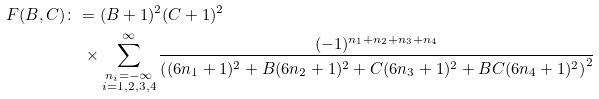Convert formula to latex. <formula><loc_0><loc_0><loc_500><loc_500>F ( B , C ) & \colon = ( B + 1 ) ^ { 2 } ( C + 1 ) ^ { 2 } \\ & \quad \times \sum _ { \substack { n _ { i } = - \infty \\ i = 1 , 2 , 3 , 4 } } ^ { \infty } \frac { ( - 1 ) ^ { n _ { 1 } + n _ { 2 } + n _ { 3 } + n _ { 4 } } } { \left ( ( 6 n _ { 1 } + 1 ) ^ { 2 } + B ( 6 n _ { 2 } + 1 ) ^ { 2 } + C ( 6 n _ { 3 } + 1 ) ^ { 2 } + B C ( 6 n _ { 4 } + 1 ) ^ { 2 } \right ) ^ { 2 } }</formula> 